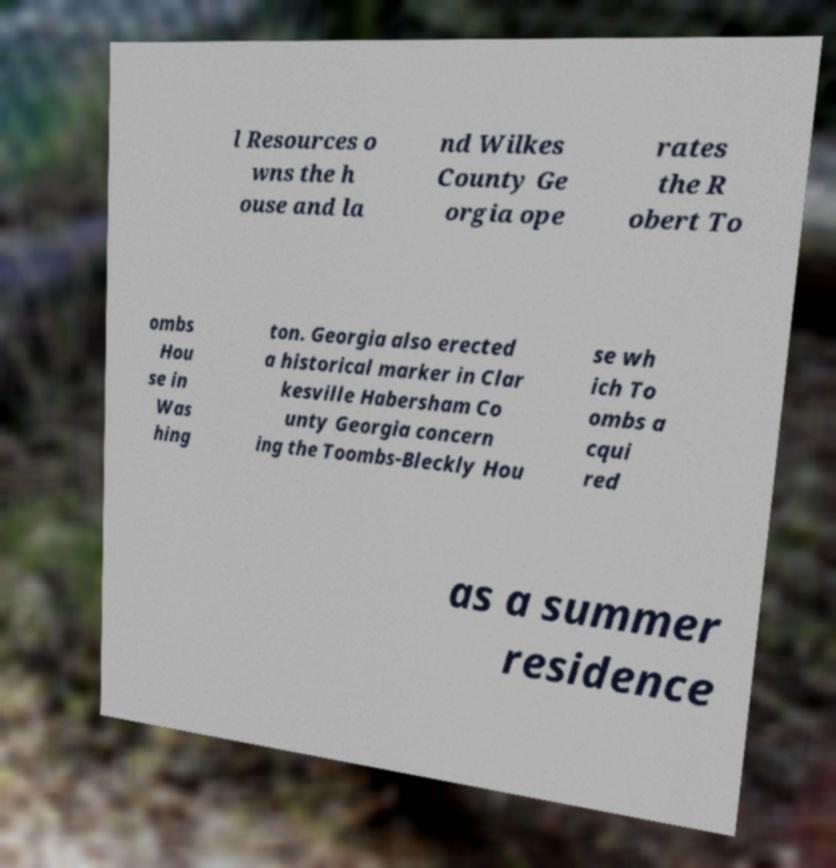I need the written content from this picture converted into text. Can you do that? l Resources o wns the h ouse and la nd Wilkes County Ge orgia ope rates the R obert To ombs Hou se in Was hing ton. Georgia also erected a historical marker in Clar kesville Habersham Co unty Georgia concern ing the Toombs-Bleckly Hou se wh ich To ombs a cqui red as a summer residence 